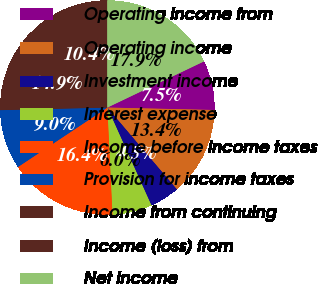Convert chart to OTSL. <chart><loc_0><loc_0><loc_500><loc_500><pie_chart><fcel>Operating income from<fcel>Operating income<fcel>Investment income<fcel>Interest expense<fcel>Income before income taxes<fcel>Provision for income taxes<fcel>Income from continuing<fcel>Income (loss) from<fcel>Net income<nl><fcel>7.46%<fcel>13.43%<fcel>4.48%<fcel>5.97%<fcel>16.42%<fcel>8.96%<fcel>14.93%<fcel>10.45%<fcel>17.91%<nl></chart> 